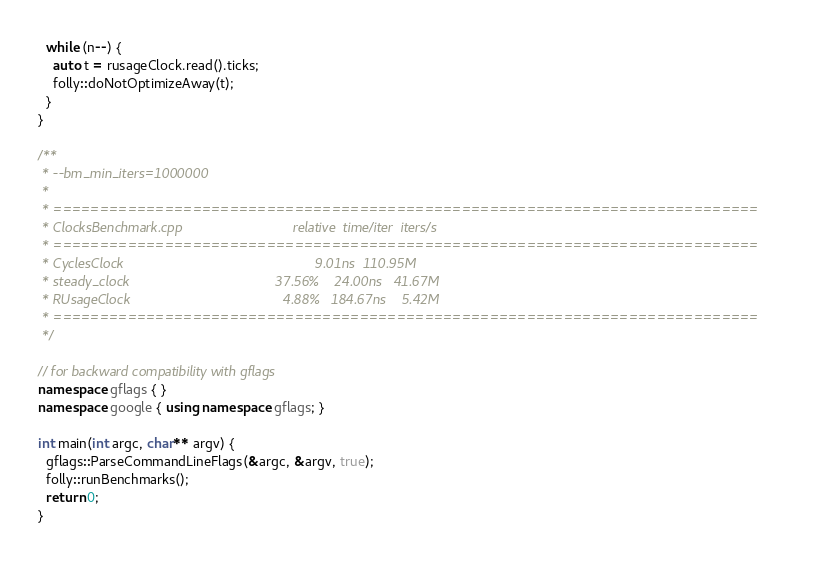Convert code to text. <code><loc_0><loc_0><loc_500><loc_500><_C++_>  while (n--) {
    auto t = rusageClock.read().ticks;
    folly::doNotOptimizeAway(t);
  }
}

/**
 * --bm_min_iters=1000000
 *
 * ============================================================================
 * ClocksBenchmark.cpp                             relative  time/iter  iters/s
 * ============================================================================
 * CyclesClock                                                  9.01ns  110.95M
 * steady_clock                                      37.56%    24.00ns   41.67M
 * RUsageClock                                        4.88%   184.67ns    5.42M
 * ============================================================================
 */

// for backward compatibility with gflags
namespace gflags { }
namespace google { using namespace gflags; }

int main(int argc, char** argv) {
  gflags::ParseCommandLineFlags(&argc, &argv, true);
  folly::runBenchmarks();
  return 0;
}
</code> 